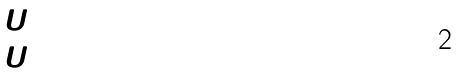<formula> <loc_0><loc_0><loc_500><loc_500>( \begin{matrix} U _ { 1 } \\ U _ { 2 } \end{matrix} )</formula> 